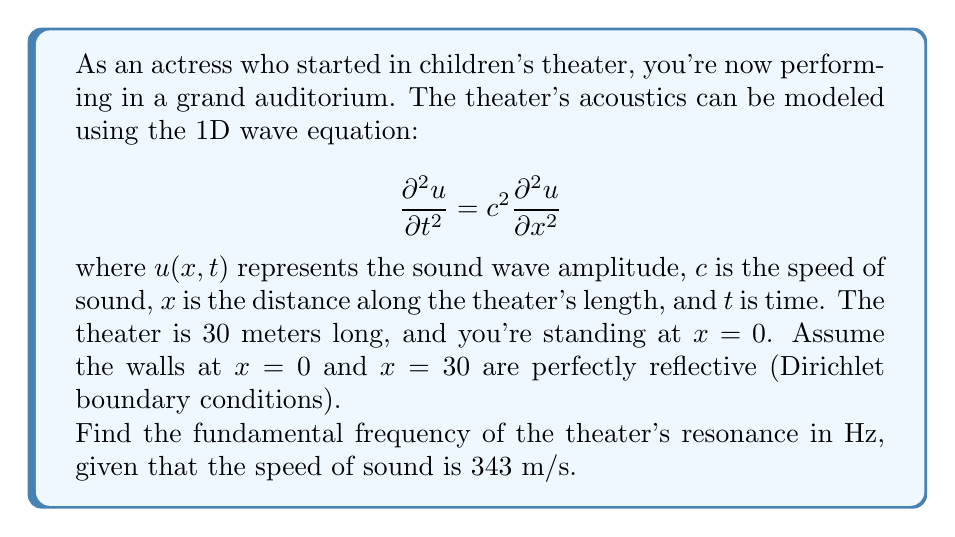What is the answer to this math problem? To solve this problem, we need to follow these steps:

1) First, we need to set up the boundary conditions. Since the walls are perfectly reflective, we have:
   
   $u(0,t) = 0$ and $u(30,t) = 0$

2) The general solution to the 1D wave equation with these boundary conditions is:

   $$u(x,t) = \sum_{n=1}^{\infty} A_n \sin(\frac{n\pi x}{L}) \cos(\frac{n\pi c t}{L})$$

   where $L$ is the length of the theater (30 m in this case).

3) The fundamental frequency corresponds to $n=1$ in this solution. The spatial part of the solution is:

   $$\sin(\frac{\pi x}{30})$$

4) The temporal part of the solution for $n=1$ is:

   $$\cos(\frac{\pi c t}{30})$$

5) The angular frequency $\omega$ of this oscillation is:

   $$\omega = \frac{\pi c}{30}$$

6) To convert from angular frequency to frequency in Hz, we use the relation $f = \frac{\omega}{2\pi}$:

   $$f = \frac{c}{2L} = \frac{343}{2(30)} = 5.7167 \text{ Hz}$$

7) Rounding to two decimal places gives us the final answer.
Answer: The fundamental frequency of the theater's resonance is approximately 5.72 Hz. 